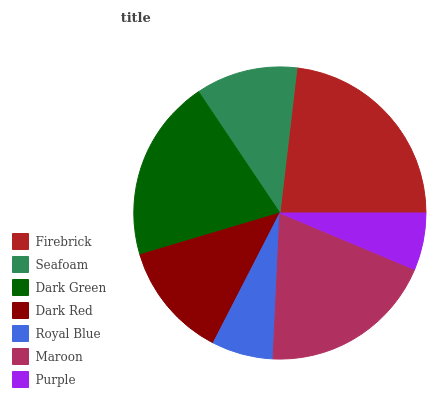Is Purple the minimum?
Answer yes or no. Yes. Is Firebrick the maximum?
Answer yes or no. Yes. Is Seafoam the minimum?
Answer yes or no. No. Is Seafoam the maximum?
Answer yes or no. No. Is Firebrick greater than Seafoam?
Answer yes or no. Yes. Is Seafoam less than Firebrick?
Answer yes or no. Yes. Is Seafoam greater than Firebrick?
Answer yes or no. No. Is Firebrick less than Seafoam?
Answer yes or no. No. Is Dark Red the high median?
Answer yes or no. Yes. Is Dark Red the low median?
Answer yes or no. Yes. Is Firebrick the high median?
Answer yes or no. No. Is Royal Blue the low median?
Answer yes or no. No. 